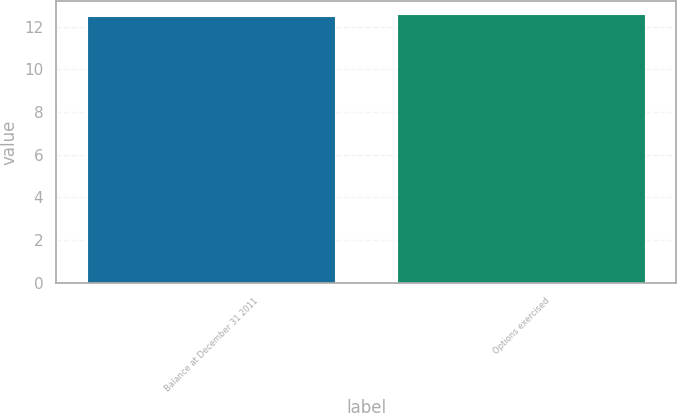<chart> <loc_0><loc_0><loc_500><loc_500><bar_chart><fcel>Balance at December 31 2011<fcel>Options exercised<nl><fcel>12.48<fcel>12.58<nl></chart> 